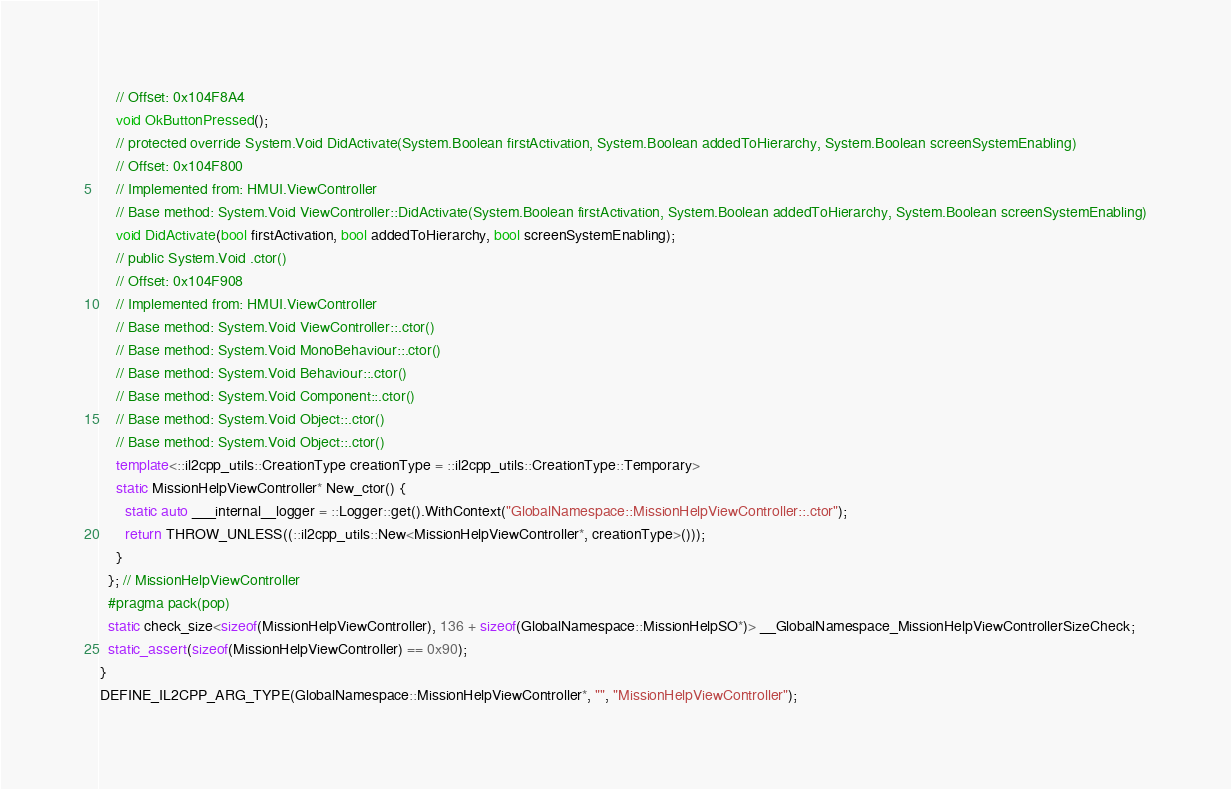<code> <loc_0><loc_0><loc_500><loc_500><_C++_>    // Offset: 0x104F8A4
    void OkButtonPressed();
    // protected override System.Void DidActivate(System.Boolean firstActivation, System.Boolean addedToHierarchy, System.Boolean screenSystemEnabling)
    // Offset: 0x104F800
    // Implemented from: HMUI.ViewController
    // Base method: System.Void ViewController::DidActivate(System.Boolean firstActivation, System.Boolean addedToHierarchy, System.Boolean screenSystemEnabling)
    void DidActivate(bool firstActivation, bool addedToHierarchy, bool screenSystemEnabling);
    // public System.Void .ctor()
    // Offset: 0x104F908
    // Implemented from: HMUI.ViewController
    // Base method: System.Void ViewController::.ctor()
    // Base method: System.Void MonoBehaviour::.ctor()
    // Base method: System.Void Behaviour::.ctor()
    // Base method: System.Void Component::.ctor()
    // Base method: System.Void Object::.ctor()
    // Base method: System.Void Object::.ctor()
    template<::il2cpp_utils::CreationType creationType = ::il2cpp_utils::CreationType::Temporary>
    static MissionHelpViewController* New_ctor() {
      static auto ___internal__logger = ::Logger::get().WithContext("GlobalNamespace::MissionHelpViewController::.ctor");
      return THROW_UNLESS((::il2cpp_utils::New<MissionHelpViewController*, creationType>()));
    }
  }; // MissionHelpViewController
  #pragma pack(pop)
  static check_size<sizeof(MissionHelpViewController), 136 + sizeof(GlobalNamespace::MissionHelpSO*)> __GlobalNamespace_MissionHelpViewControllerSizeCheck;
  static_assert(sizeof(MissionHelpViewController) == 0x90);
}
DEFINE_IL2CPP_ARG_TYPE(GlobalNamespace::MissionHelpViewController*, "", "MissionHelpViewController");
</code> 